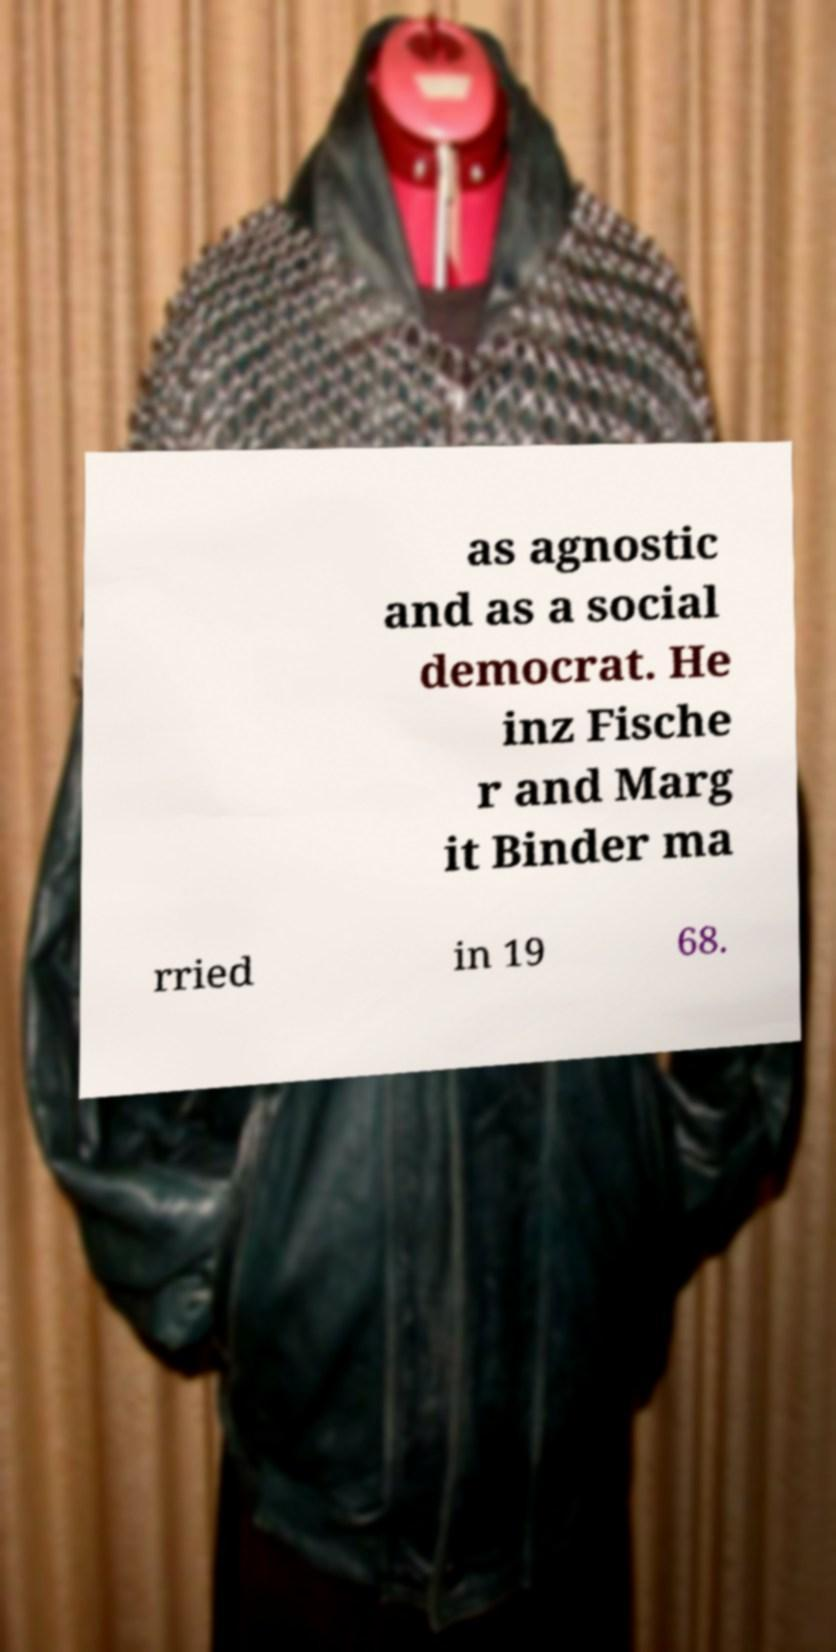What messages or text are displayed in this image? I need them in a readable, typed format. as agnostic and as a social democrat. He inz Fische r and Marg it Binder ma rried in 19 68. 